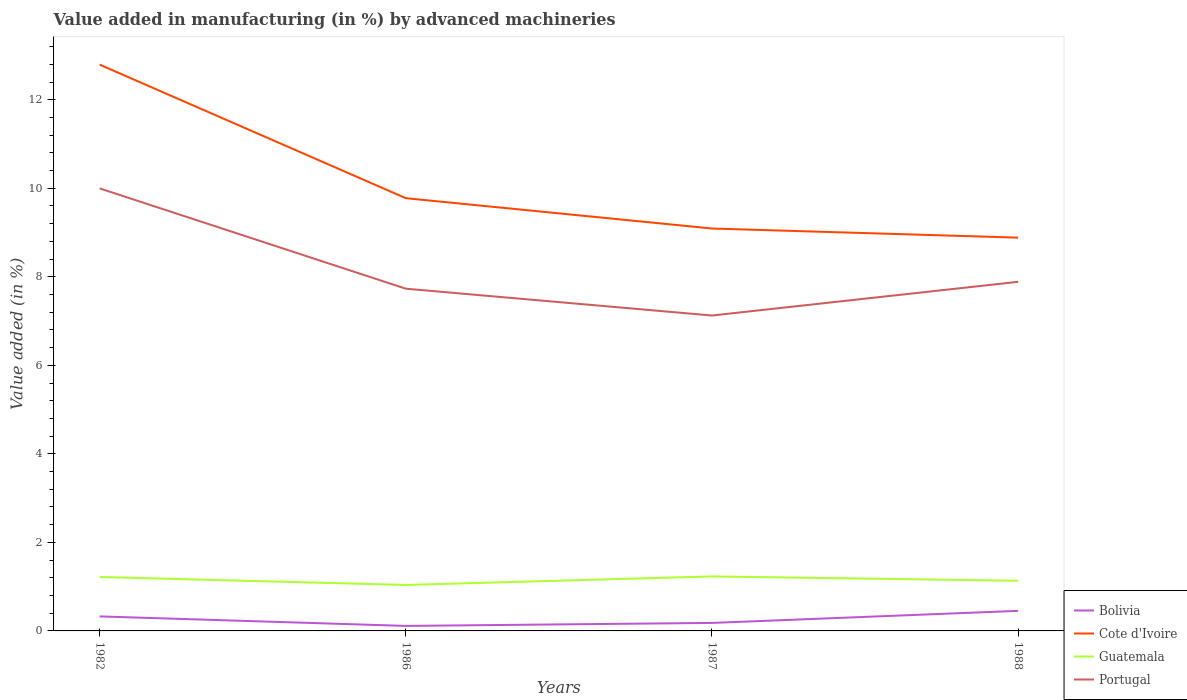How many different coloured lines are there?
Make the answer very short. 4. Does the line corresponding to Cote d'Ivoire intersect with the line corresponding to Bolivia?
Ensure brevity in your answer.  No. Is the number of lines equal to the number of legend labels?
Provide a short and direct response. Yes. Across all years, what is the maximum percentage of value added in manufacturing by advanced machineries in Bolivia?
Offer a terse response. 0.11. In which year was the percentage of value added in manufacturing by advanced machineries in Portugal maximum?
Offer a very short reply. 1987. What is the total percentage of value added in manufacturing by advanced machineries in Portugal in the graph?
Offer a terse response. 2.27. What is the difference between the highest and the second highest percentage of value added in manufacturing by advanced machineries in Cote d'Ivoire?
Keep it short and to the point. 3.91. What is the difference between the highest and the lowest percentage of value added in manufacturing by advanced machineries in Guatemala?
Your response must be concise. 2. How many years are there in the graph?
Your response must be concise. 4. Are the values on the major ticks of Y-axis written in scientific E-notation?
Your answer should be compact. No. How many legend labels are there?
Your answer should be compact. 4. What is the title of the graph?
Give a very brief answer. Value added in manufacturing (in %) by advanced machineries. Does "United States" appear as one of the legend labels in the graph?
Your answer should be very brief. No. What is the label or title of the Y-axis?
Ensure brevity in your answer.  Value added (in %). What is the Value added (in %) in Bolivia in 1982?
Give a very brief answer. 0.33. What is the Value added (in %) of Cote d'Ivoire in 1982?
Provide a succinct answer. 12.79. What is the Value added (in %) in Guatemala in 1982?
Make the answer very short. 1.22. What is the Value added (in %) of Portugal in 1982?
Your response must be concise. 10. What is the Value added (in %) in Bolivia in 1986?
Your answer should be compact. 0.11. What is the Value added (in %) in Cote d'Ivoire in 1986?
Provide a short and direct response. 9.78. What is the Value added (in %) in Guatemala in 1986?
Your response must be concise. 1.04. What is the Value added (in %) in Portugal in 1986?
Give a very brief answer. 7.73. What is the Value added (in %) in Bolivia in 1987?
Give a very brief answer. 0.18. What is the Value added (in %) in Cote d'Ivoire in 1987?
Give a very brief answer. 9.09. What is the Value added (in %) of Guatemala in 1987?
Provide a succinct answer. 1.23. What is the Value added (in %) of Portugal in 1987?
Your answer should be compact. 7.13. What is the Value added (in %) in Bolivia in 1988?
Provide a succinct answer. 0.45. What is the Value added (in %) in Cote d'Ivoire in 1988?
Make the answer very short. 8.88. What is the Value added (in %) of Guatemala in 1988?
Ensure brevity in your answer.  1.13. What is the Value added (in %) of Portugal in 1988?
Offer a very short reply. 7.89. Across all years, what is the maximum Value added (in %) in Bolivia?
Your answer should be compact. 0.45. Across all years, what is the maximum Value added (in %) in Cote d'Ivoire?
Your answer should be compact. 12.79. Across all years, what is the maximum Value added (in %) of Guatemala?
Your answer should be compact. 1.23. Across all years, what is the maximum Value added (in %) of Portugal?
Your response must be concise. 10. Across all years, what is the minimum Value added (in %) in Bolivia?
Make the answer very short. 0.11. Across all years, what is the minimum Value added (in %) of Cote d'Ivoire?
Offer a very short reply. 8.88. Across all years, what is the minimum Value added (in %) of Guatemala?
Give a very brief answer. 1.04. Across all years, what is the minimum Value added (in %) in Portugal?
Make the answer very short. 7.13. What is the total Value added (in %) of Bolivia in the graph?
Make the answer very short. 1.08. What is the total Value added (in %) in Cote d'Ivoire in the graph?
Offer a very short reply. 40.54. What is the total Value added (in %) of Guatemala in the graph?
Offer a very short reply. 4.62. What is the total Value added (in %) in Portugal in the graph?
Make the answer very short. 32.74. What is the difference between the Value added (in %) of Bolivia in 1982 and that in 1986?
Offer a terse response. 0.21. What is the difference between the Value added (in %) of Cote d'Ivoire in 1982 and that in 1986?
Provide a short and direct response. 3.02. What is the difference between the Value added (in %) of Guatemala in 1982 and that in 1986?
Ensure brevity in your answer.  0.18. What is the difference between the Value added (in %) in Portugal in 1982 and that in 1986?
Keep it short and to the point. 2.27. What is the difference between the Value added (in %) of Bolivia in 1982 and that in 1987?
Provide a succinct answer. 0.15. What is the difference between the Value added (in %) in Cote d'Ivoire in 1982 and that in 1987?
Ensure brevity in your answer.  3.7. What is the difference between the Value added (in %) of Guatemala in 1982 and that in 1987?
Ensure brevity in your answer.  -0.01. What is the difference between the Value added (in %) in Portugal in 1982 and that in 1987?
Your answer should be compact. 2.87. What is the difference between the Value added (in %) of Bolivia in 1982 and that in 1988?
Your response must be concise. -0.13. What is the difference between the Value added (in %) of Cote d'Ivoire in 1982 and that in 1988?
Provide a succinct answer. 3.91. What is the difference between the Value added (in %) in Guatemala in 1982 and that in 1988?
Keep it short and to the point. 0.09. What is the difference between the Value added (in %) in Portugal in 1982 and that in 1988?
Keep it short and to the point. 2.11. What is the difference between the Value added (in %) of Bolivia in 1986 and that in 1987?
Provide a succinct answer. -0.07. What is the difference between the Value added (in %) in Cote d'Ivoire in 1986 and that in 1987?
Your answer should be compact. 0.69. What is the difference between the Value added (in %) in Guatemala in 1986 and that in 1987?
Your response must be concise. -0.19. What is the difference between the Value added (in %) of Portugal in 1986 and that in 1987?
Provide a succinct answer. 0.61. What is the difference between the Value added (in %) of Bolivia in 1986 and that in 1988?
Your answer should be very brief. -0.34. What is the difference between the Value added (in %) of Cote d'Ivoire in 1986 and that in 1988?
Offer a terse response. 0.89. What is the difference between the Value added (in %) of Guatemala in 1986 and that in 1988?
Offer a very short reply. -0.09. What is the difference between the Value added (in %) of Portugal in 1986 and that in 1988?
Keep it short and to the point. -0.16. What is the difference between the Value added (in %) of Bolivia in 1987 and that in 1988?
Your answer should be very brief. -0.27. What is the difference between the Value added (in %) in Cote d'Ivoire in 1987 and that in 1988?
Offer a terse response. 0.21. What is the difference between the Value added (in %) of Guatemala in 1987 and that in 1988?
Make the answer very short. 0.1. What is the difference between the Value added (in %) of Portugal in 1987 and that in 1988?
Your response must be concise. -0.76. What is the difference between the Value added (in %) in Bolivia in 1982 and the Value added (in %) in Cote d'Ivoire in 1986?
Offer a very short reply. -9.45. What is the difference between the Value added (in %) in Bolivia in 1982 and the Value added (in %) in Guatemala in 1986?
Ensure brevity in your answer.  -0.71. What is the difference between the Value added (in %) of Bolivia in 1982 and the Value added (in %) of Portugal in 1986?
Keep it short and to the point. -7.4. What is the difference between the Value added (in %) in Cote d'Ivoire in 1982 and the Value added (in %) in Guatemala in 1986?
Provide a succinct answer. 11.75. What is the difference between the Value added (in %) in Cote d'Ivoire in 1982 and the Value added (in %) in Portugal in 1986?
Provide a short and direct response. 5.06. What is the difference between the Value added (in %) of Guatemala in 1982 and the Value added (in %) of Portugal in 1986?
Give a very brief answer. -6.51. What is the difference between the Value added (in %) in Bolivia in 1982 and the Value added (in %) in Cote d'Ivoire in 1987?
Offer a very short reply. -8.76. What is the difference between the Value added (in %) of Bolivia in 1982 and the Value added (in %) of Guatemala in 1987?
Offer a very short reply. -0.9. What is the difference between the Value added (in %) of Bolivia in 1982 and the Value added (in %) of Portugal in 1987?
Offer a very short reply. -6.8. What is the difference between the Value added (in %) in Cote d'Ivoire in 1982 and the Value added (in %) in Guatemala in 1987?
Give a very brief answer. 11.56. What is the difference between the Value added (in %) in Cote d'Ivoire in 1982 and the Value added (in %) in Portugal in 1987?
Offer a very short reply. 5.67. What is the difference between the Value added (in %) of Guatemala in 1982 and the Value added (in %) of Portugal in 1987?
Provide a succinct answer. -5.91. What is the difference between the Value added (in %) of Bolivia in 1982 and the Value added (in %) of Cote d'Ivoire in 1988?
Your answer should be very brief. -8.56. What is the difference between the Value added (in %) of Bolivia in 1982 and the Value added (in %) of Guatemala in 1988?
Your response must be concise. -0.81. What is the difference between the Value added (in %) of Bolivia in 1982 and the Value added (in %) of Portugal in 1988?
Offer a very short reply. -7.56. What is the difference between the Value added (in %) of Cote d'Ivoire in 1982 and the Value added (in %) of Guatemala in 1988?
Your answer should be very brief. 11.66. What is the difference between the Value added (in %) in Cote d'Ivoire in 1982 and the Value added (in %) in Portugal in 1988?
Your response must be concise. 4.91. What is the difference between the Value added (in %) in Guatemala in 1982 and the Value added (in %) in Portugal in 1988?
Provide a succinct answer. -6.67. What is the difference between the Value added (in %) of Bolivia in 1986 and the Value added (in %) of Cote d'Ivoire in 1987?
Offer a very short reply. -8.98. What is the difference between the Value added (in %) in Bolivia in 1986 and the Value added (in %) in Guatemala in 1987?
Keep it short and to the point. -1.12. What is the difference between the Value added (in %) of Bolivia in 1986 and the Value added (in %) of Portugal in 1987?
Offer a terse response. -7.01. What is the difference between the Value added (in %) in Cote d'Ivoire in 1986 and the Value added (in %) in Guatemala in 1987?
Provide a succinct answer. 8.54. What is the difference between the Value added (in %) in Cote d'Ivoire in 1986 and the Value added (in %) in Portugal in 1987?
Give a very brief answer. 2.65. What is the difference between the Value added (in %) in Guatemala in 1986 and the Value added (in %) in Portugal in 1987?
Your answer should be very brief. -6.09. What is the difference between the Value added (in %) of Bolivia in 1986 and the Value added (in %) of Cote d'Ivoire in 1988?
Keep it short and to the point. -8.77. What is the difference between the Value added (in %) in Bolivia in 1986 and the Value added (in %) in Guatemala in 1988?
Make the answer very short. -1.02. What is the difference between the Value added (in %) in Bolivia in 1986 and the Value added (in %) in Portugal in 1988?
Ensure brevity in your answer.  -7.77. What is the difference between the Value added (in %) of Cote d'Ivoire in 1986 and the Value added (in %) of Guatemala in 1988?
Keep it short and to the point. 8.64. What is the difference between the Value added (in %) in Cote d'Ivoire in 1986 and the Value added (in %) in Portugal in 1988?
Offer a terse response. 1.89. What is the difference between the Value added (in %) of Guatemala in 1986 and the Value added (in %) of Portugal in 1988?
Offer a terse response. -6.85. What is the difference between the Value added (in %) of Bolivia in 1987 and the Value added (in %) of Cote d'Ivoire in 1988?
Your answer should be compact. -8.7. What is the difference between the Value added (in %) of Bolivia in 1987 and the Value added (in %) of Guatemala in 1988?
Keep it short and to the point. -0.95. What is the difference between the Value added (in %) in Bolivia in 1987 and the Value added (in %) in Portugal in 1988?
Keep it short and to the point. -7.71. What is the difference between the Value added (in %) of Cote d'Ivoire in 1987 and the Value added (in %) of Guatemala in 1988?
Your response must be concise. 7.96. What is the difference between the Value added (in %) of Cote d'Ivoire in 1987 and the Value added (in %) of Portugal in 1988?
Offer a very short reply. 1.2. What is the difference between the Value added (in %) of Guatemala in 1987 and the Value added (in %) of Portugal in 1988?
Offer a very short reply. -6.66. What is the average Value added (in %) of Bolivia per year?
Keep it short and to the point. 0.27. What is the average Value added (in %) of Cote d'Ivoire per year?
Give a very brief answer. 10.14. What is the average Value added (in %) in Guatemala per year?
Provide a succinct answer. 1.16. What is the average Value added (in %) in Portugal per year?
Offer a terse response. 8.19. In the year 1982, what is the difference between the Value added (in %) in Bolivia and Value added (in %) in Cote d'Ivoire?
Your answer should be compact. -12.47. In the year 1982, what is the difference between the Value added (in %) of Bolivia and Value added (in %) of Guatemala?
Your answer should be very brief. -0.89. In the year 1982, what is the difference between the Value added (in %) in Bolivia and Value added (in %) in Portugal?
Provide a succinct answer. -9.67. In the year 1982, what is the difference between the Value added (in %) of Cote d'Ivoire and Value added (in %) of Guatemala?
Your response must be concise. 11.57. In the year 1982, what is the difference between the Value added (in %) in Cote d'Ivoire and Value added (in %) in Portugal?
Offer a terse response. 2.8. In the year 1982, what is the difference between the Value added (in %) of Guatemala and Value added (in %) of Portugal?
Provide a short and direct response. -8.78. In the year 1986, what is the difference between the Value added (in %) of Bolivia and Value added (in %) of Cote d'Ivoire?
Your response must be concise. -9.66. In the year 1986, what is the difference between the Value added (in %) of Bolivia and Value added (in %) of Guatemala?
Give a very brief answer. -0.93. In the year 1986, what is the difference between the Value added (in %) of Bolivia and Value added (in %) of Portugal?
Give a very brief answer. -7.62. In the year 1986, what is the difference between the Value added (in %) of Cote d'Ivoire and Value added (in %) of Guatemala?
Ensure brevity in your answer.  8.74. In the year 1986, what is the difference between the Value added (in %) of Cote d'Ivoire and Value added (in %) of Portugal?
Ensure brevity in your answer.  2.04. In the year 1986, what is the difference between the Value added (in %) of Guatemala and Value added (in %) of Portugal?
Offer a very short reply. -6.69. In the year 1987, what is the difference between the Value added (in %) in Bolivia and Value added (in %) in Cote d'Ivoire?
Your response must be concise. -8.91. In the year 1987, what is the difference between the Value added (in %) in Bolivia and Value added (in %) in Guatemala?
Offer a terse response. -1.05. In the year 1987, what is the difference between the Value added (in %) in Bolivia and Value added (in %) in Portugal?
Your answer should be very brief. -6.94. In the year 1987, what is the difference between the Value added (in %) of Cote d'Ivoire and Value added (in %) of Guatemala?
Make the answer very short. 7.86. In the year 1987, what is the difference between the Value added (in %) in Cote d'Ivoire and Value added (in %) in Portugal?
Your answer should be very brief. 1.97. In the year 1987, what is the difference between the Value added (in %) in Guatemala and Value added (in %) in Portugal?
Your response must be concise. -5.89. In the year 1988, what is the difference between the Value added (in %) of Bolivia and Value added (in %) of Cote d'Ivoire?
Provide a succinct answer. -8.43. In the year 1988, what is the difference between the Value added (in %) in Bolivia and Value added (in %) in Guatemala?
Offer a terse response. -0.68. In the year 1988, what is the difference between the Value added (in %) in Bolivia and Value added (in %) in Portugal?
Provide a short and direct response. -7.43. In the year 1988, what is the difference between the Value added (in %) in Cote d'Ivoire and Value added (in %) in Guatemala?
Offer a very short reply. 7.75. In the year 1988, what is the difference between the Value added (in %) in Cote d'Ivoire and Value added (in %) in Portugal?
Make the answer very short. 1. In the year 1988, what is the difference between the Value added (in %) in Guatemala and Value added (in %) in Portugal?
Your answer should be very brief. -6.75. What is the ratio of the Value added (in %) in Bolivia in 1982 to that in 1986?
Provide a short and direct response. 2.89. What is the ratio of the Value added (in %) in Cote d'Ivoire in 1982 to that in 1986?
Offer a very short reply. 1.31. What is the ratio of the Value added (in %) in Guatemala in 1982 to that in 1986?
Your answer should be compact. 1.17. What is the ratio of the Value added (in %) in Portugal in 1982 to that in 1986?
Offer a very short reply. 1.29. What is the ratio of the Value added (in %) of Bolivia in 1982 to that in 1987?
Make the answer very short. 1.81. What is the ratio of the Value added (in %) of Cote d'Ivoire in 1982 to that in 1987?
Keep it short and to the point. 1.41. What is the ratio of the Value added (in %) in Guatemala in 1982 to that in 1987?
Your response must be concise. 0.99. What is the ratio of the Value added (in %) in Portugal in 1982 to that in 1987?
Provide a short and direct response. 1.4. What is the ratio of the Value added (in %) in Bolivia in 1982 to that in 1988?
Offer a very short reply. 0.72. What is the ratio of the Value added (in %) of Cote d'Ivoire in 1982 to that in 1988?
Give a very brief answer. 1.44. What is the ratio of the Value added (in %) in Guatemala in 1982 to that in 1988?
Provide a succinct answer. 1.07. What is the ratio of the Value added (in %) of Portugal in 1982 to that in 1988?
Provide a short and direct response. 1.27. What is the ratio of the Value added (in %) in Bolivia in 1986 to that in 1987?
Offer a very short reply. 0.63. What is the ratio of the Value added (in %) of Cote d'Ivoire in 1986 to that in 1987?
Your answer should be very brief. 1.08. What is the ratio of the Value added (in %) of Guatemala in 1986 to that in 1987?
Make the answer very short. 0.84. What is the ratio of the Value added (in %) in Portugal in 1986 to that in 1987?
Offer a very short reply. 1.08. What is the ratio of the Value added (in %) of Bolivia in 1986 to that in 1988?
Offer a very short reply. 0.25. What is the ratio of the Value added (in %) of Cote d'Ivoire in 1986 to that in 1988?
Make the answer very short. 1.1. What is the ratio of the Value added (in %) in Guatemala in 1986 to that in 1988?
Make the answer very short. 0.92. What is the ratio of the Value added (in %) in Portugal in 1986 to that in 1988?
Provide a short and direct response. 0.98. What is the ratio of the Value added (in %) of Bolivia in 1987 to that in 1988?
Provide a short and direct response. 0.4. What is the ratio of the Value added (in %) in Cote d'Ivoire in 1987 to that in 1988?
Offer a terse response. 1.02. What is the ratio of the Value added (in %) of Guatemala in 1987 to that in 1988?
Provide a succinct answer. 1.09. What is the ratio of the Value added (in %) of Portugal in 1987 to that in 1988?
Keep it short and to the point. 0.9. What is the difference between the highest and the second highest Value added (in %) of Bolivia?
Keep it short and to the point. 0.13. What is the difference between the highest and the second highest Value added (in %) in Cote d'Ivoire?
Give a very brief answer. 3.02. What is the difference between the highest and the second highest Value added (in %) of Guatemala?
Provide a succinct answer. 0.01. What is the difference between the highest and the second highest Value added (in %) in Portugal?
Give a very brief answer. 2.11. What is the difference between the highest and the lowest Value added (in %) of Bolivia?
Ensure brevity in your answer.  0.34. What is the difference between the highest and the lowest Value added (in %) in Cote d'Ivoire?
Make the answer very short. 3.91. What is the difference between the highest and the lowest Value added (in %) of Guatemala?
Keep it short and to the point. 0.19. What is the difference between the highest and the lowest Value added (in %) in Portugal?
Offer a terse response. 2.87. 